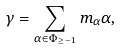<formula> <loc_0><loc_0><loc_500><loc_500>\gamma = \sum _ { \alpha \in \Phi _ { \geq - 1 } } m _ { \alpha } \alpha ,</formula> 